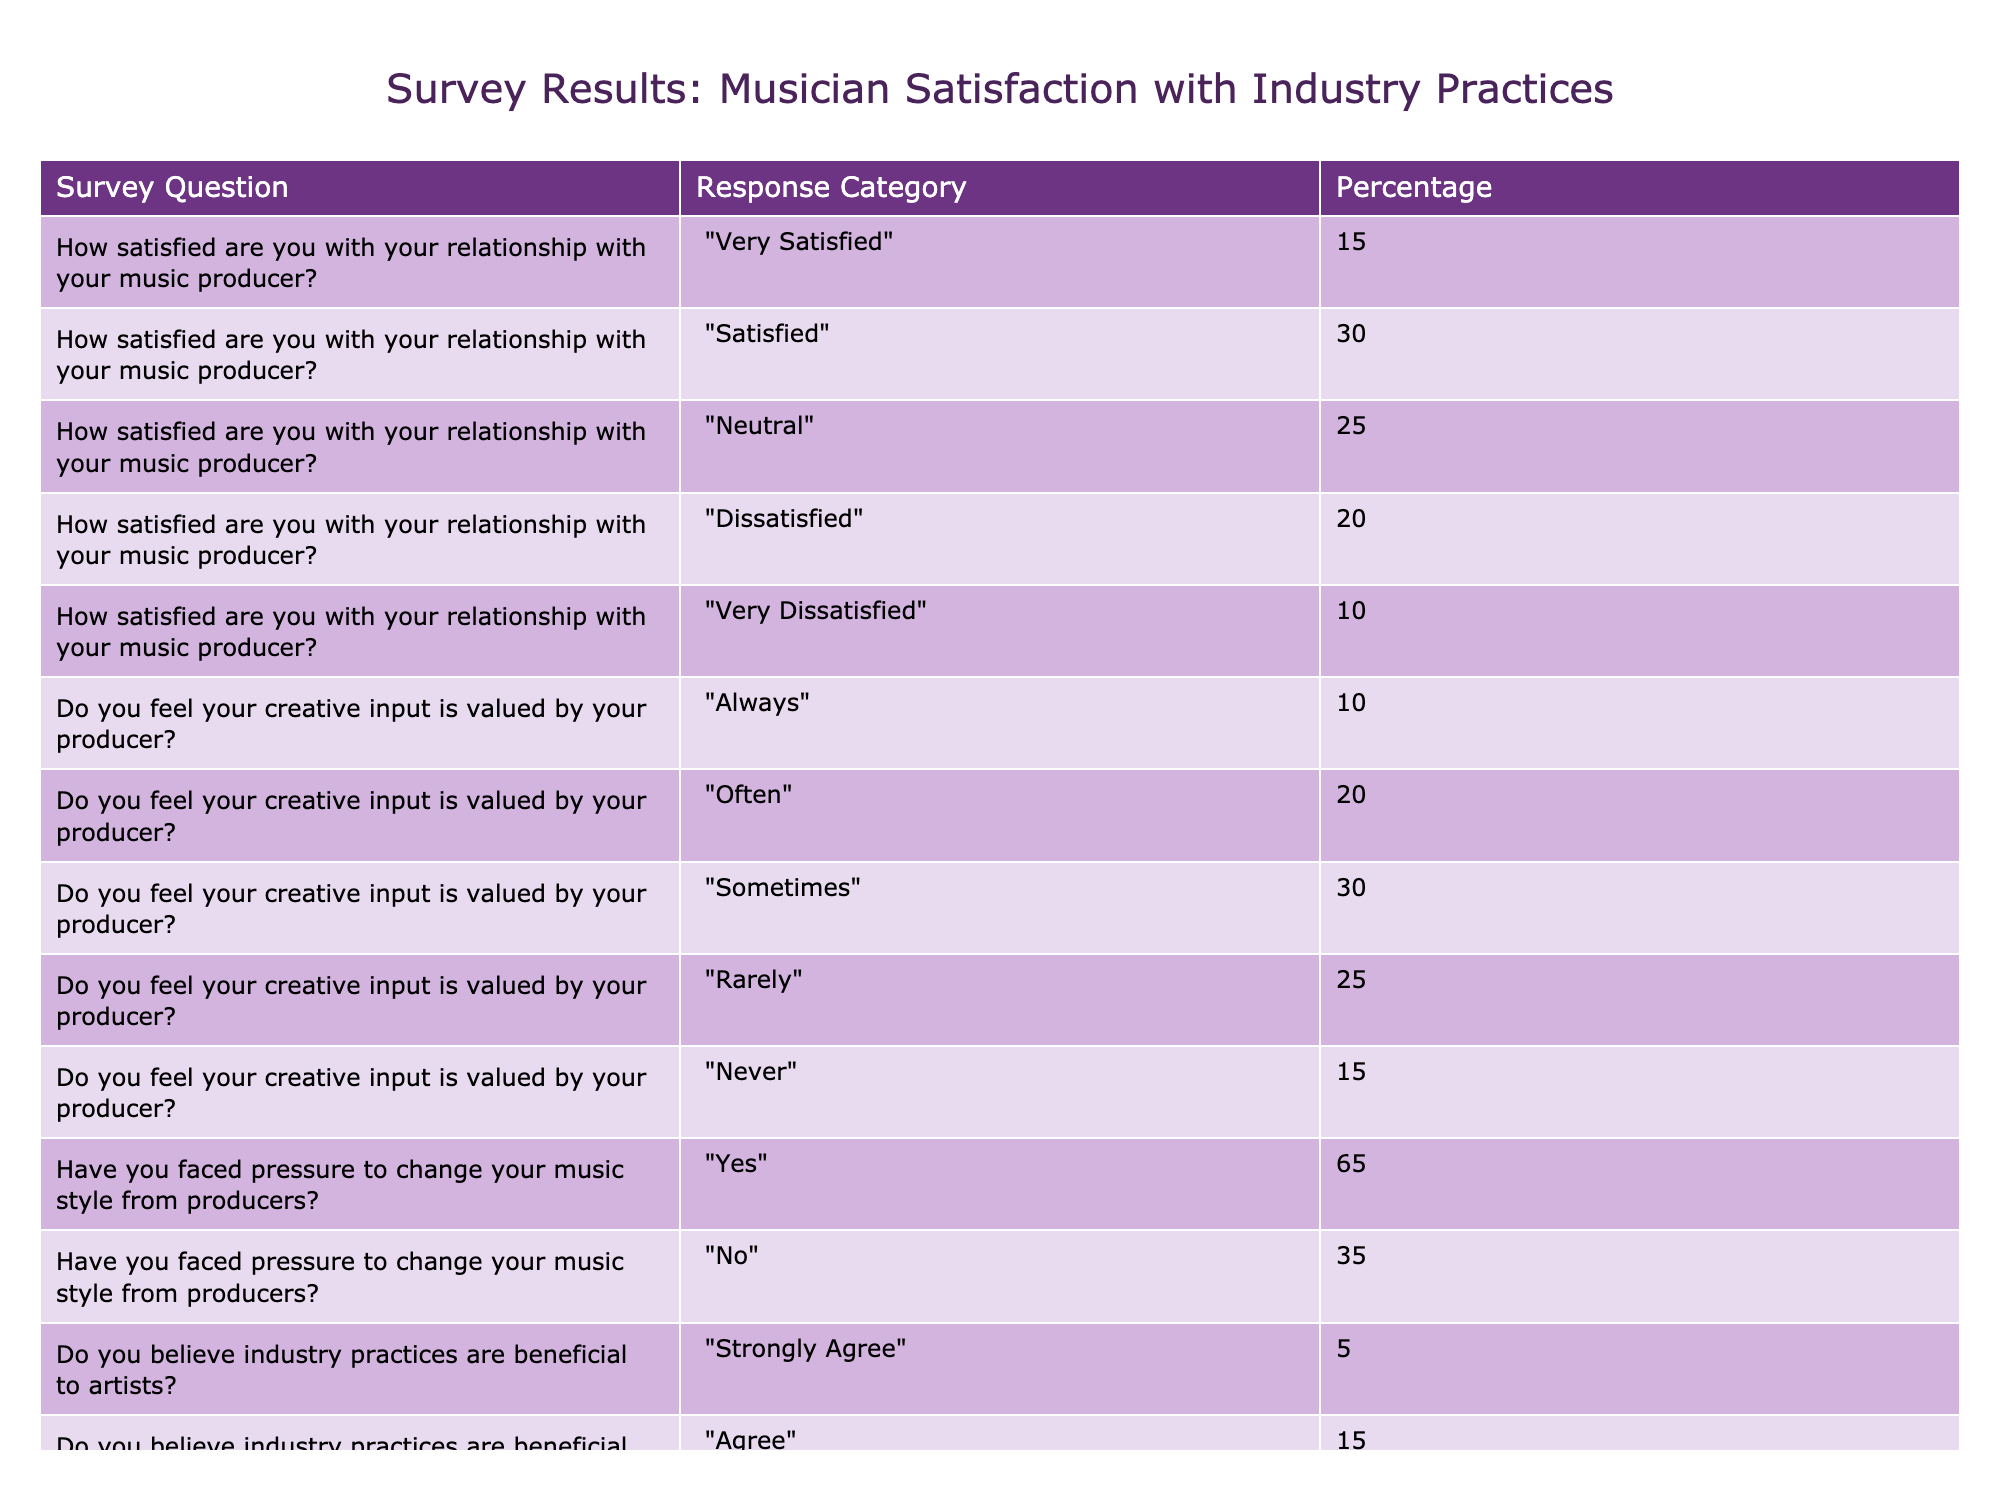What percentage of musicians are very satisfied with their relationship with their music producer? From the table, the response category "Very Satisfied" has a percentage of 15% linked to the survey question about satisfaction with the producer relationship. Therefore, the answer is directly visible in the table.
Answer: 15% What is the total percentage of musicians who feel their creative input is valued by their producer (Always + Often + Sometimes)? To get the total, we sum the percentages for the response categories "Always" (10%), "Often" (20%), and "Sometimes" (30%). Thus, the total is 10 + 20 + 30 = 60%.
Answer: 60% Is it true that more than half of the musicians have faced pressure to change their music style from producers? The table shows that 65% of musicians responded "Yes" to facing pressure to change their music style, which is greater than 50%. Hence, this statement is true.
Answer: Yes What is the difference in percentage between musicians who disagree and those who strongly agree that industry practices are beneficial to artists? The percentage for "Agree" is 15% and for "Strongly Agree" it is 5%. To find the difference, we need to subtract: 30 - 5 = 25%. Thus, the difference is 25%.
Answer: 25% What percentage of musicians are dissatisfied (Dissatisfied + Very Dissatisfied) with their relationship with their music producer? The value for "Dissatisfied" is 20% and for "Very Dissatisfied" is 10%. To calculate the total percentage of dissatisfied musicians, we add these values: 20 + 10 = 30%.
Answer: 30% What is the median percentage of musicians who feel that industry practices are beneficial or not? The provided data points for industry practices are: Strongly Agree (5%), Agree (15%), Neutral (25%), Disagree (30%), and Strongly Disagree (25%). When arranged in ascending order [5, 15, 25, 25, 30], the median is the middle value, which is 25%.
Answer: 25% How many more musicians report being dissatisfied with their relationship with their music producer compared to those who are very satisfied? The percentage of musicians dissatisfied (20% + 10% = 30%) is compared to very satisfied (15%). Therefore, the difference is: 30 - 15 = 15%, indicating more musicians are dissatisfied.
Answer: 15% Is the percentage of musicians who feel their creative input is valued always or often greater than those who feel it is valued rarely or never? "Always" (10%) + "Often" (20%) gives a total of 30%, while "Rarely" (25%) + "Never" (15%) totals to 40%. Therefore, 30% is less than 40%, making the statement false.
Answer: No 